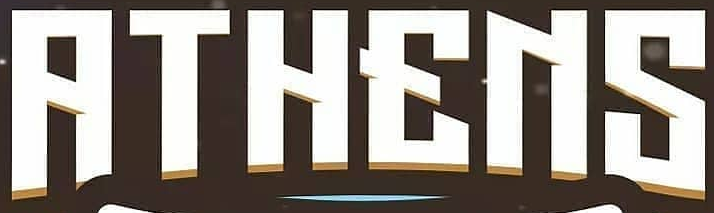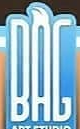Read the text content from these images in order, separated by a semicolon. RTHENS; BAG 